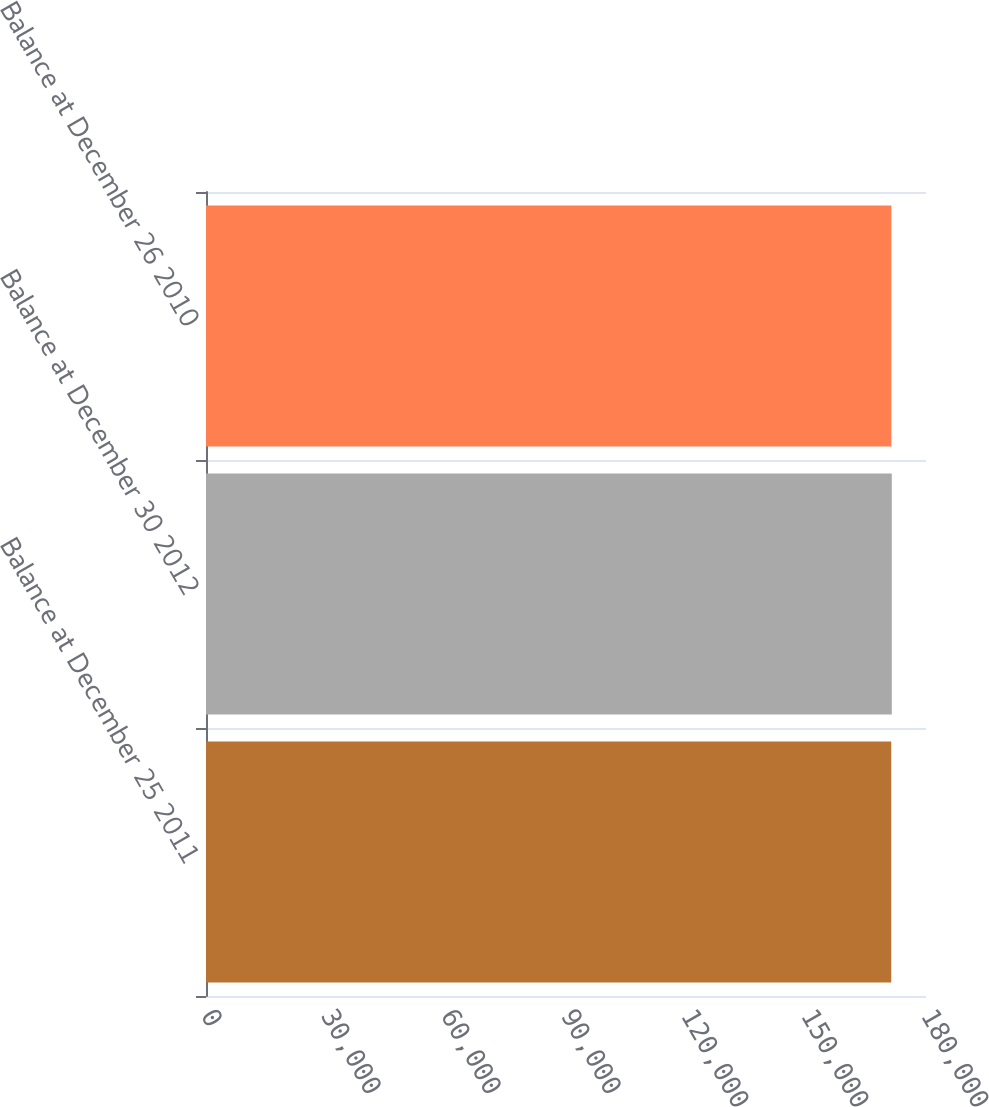Convert chart to OTSL. <chart><loc_0><loc_0><loc_500><loc_500><bar_chart><fcel>Balance at December 25 2011<fcel>Balance at December 30 2012<fcel>Balance at December 26 2010<nl><fcel>171318<fcel>171451<fcel>171339<nl></chart> 